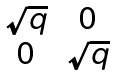Convert formula to latex. <formula><loc_0><loc_0><loc_500><loc_500>\begin{matrix} \sqrt { q } & 0 \\ 0 & \sqrt { q } \end{matrix}</formula> 